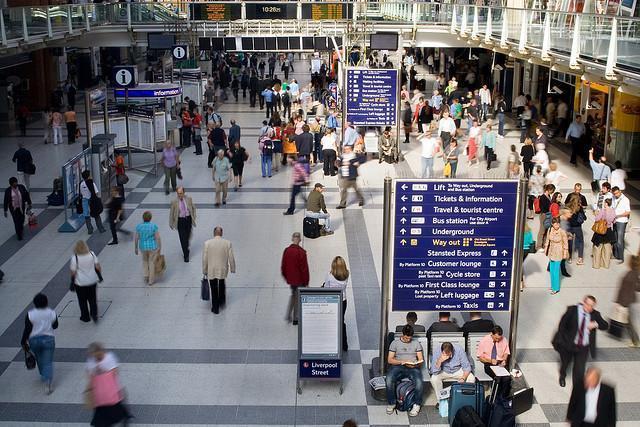How many people are in the photo?
Give a very brief answer. 6. How many train cars are painted black?
Give a very brief answer. 0. 